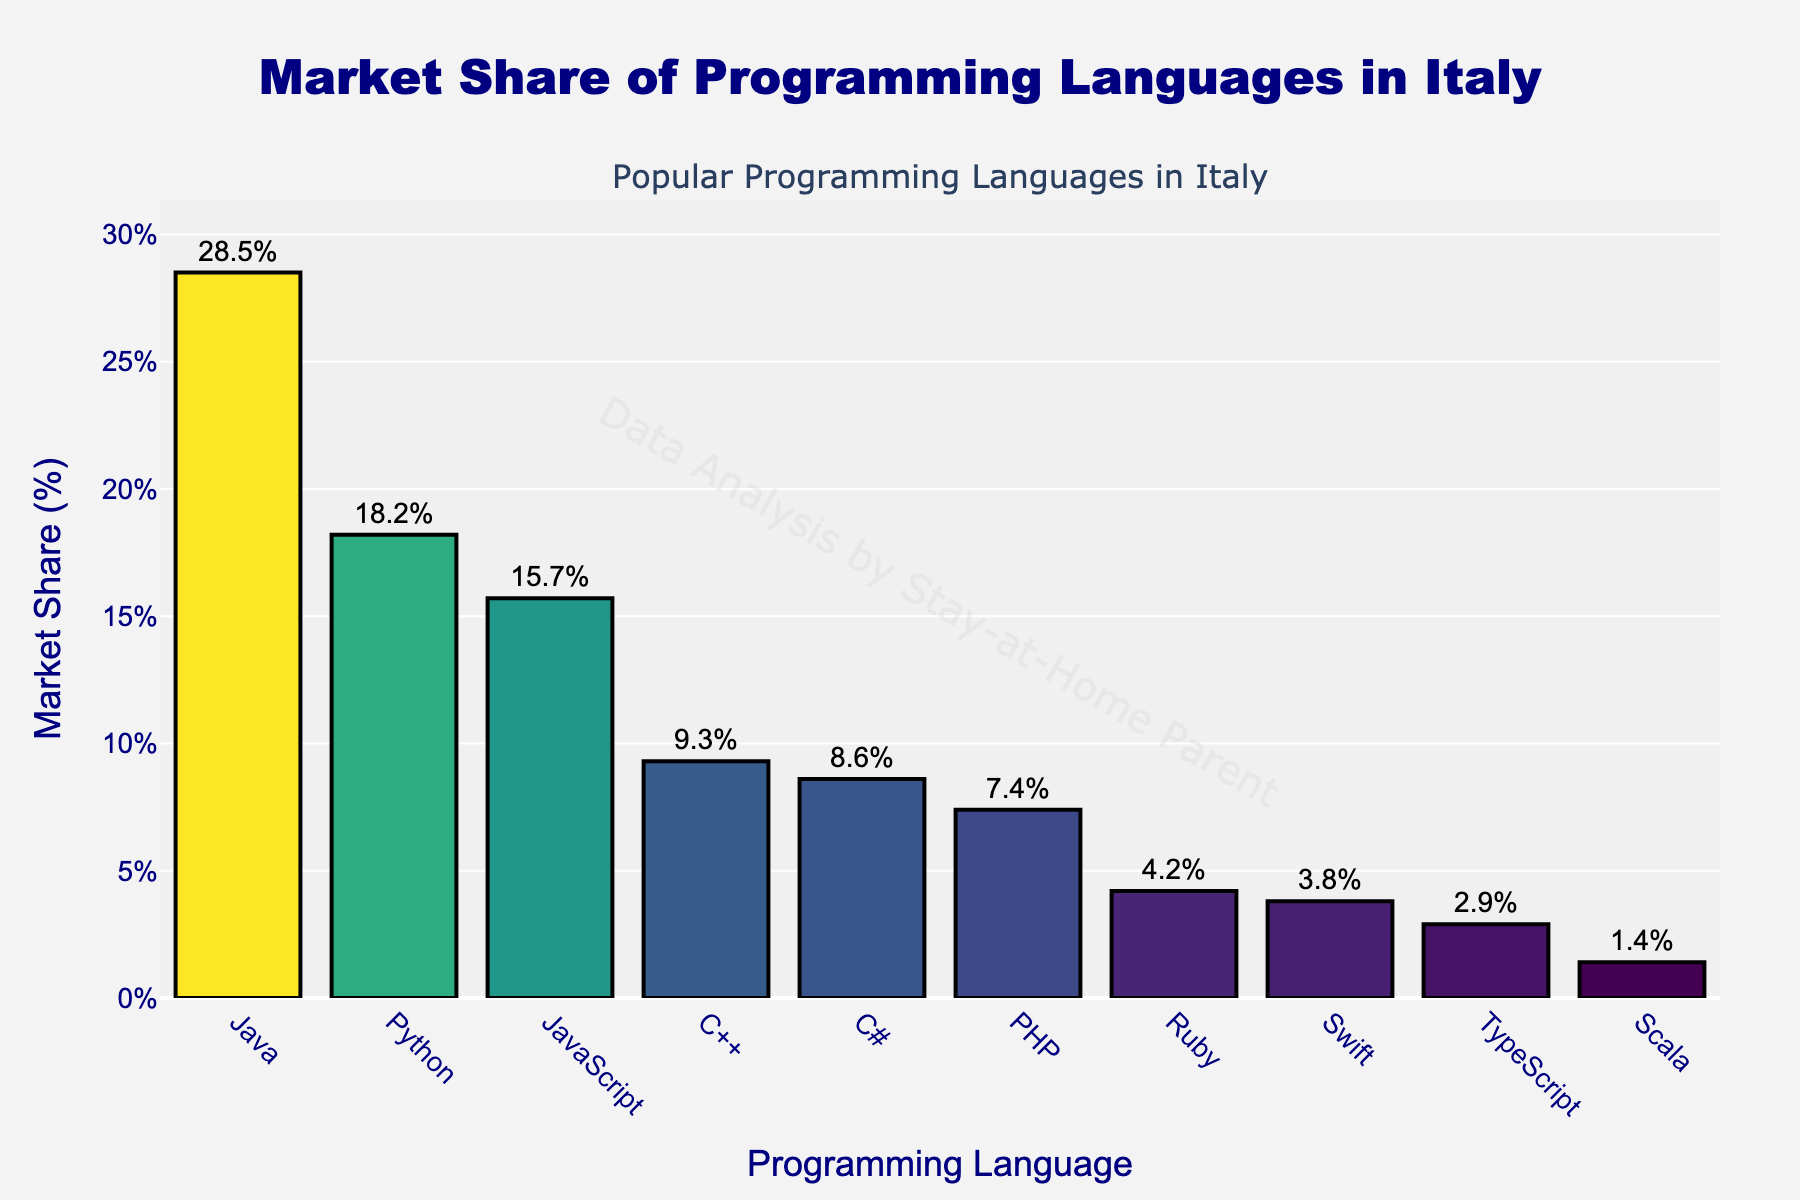What is the most popular programming language in Italy by market share? The figure shows the market share of various programming languages in Italy. The bar with the highest value represents the most popular language.
Answer: Java Which programming language has a market share greater than 10% but less than Java's market share? From the figure, identify the languages with market shares greater than 10%. Then, among those, find the one whose market share is less than Java's 28.5%.
Answer: Python Compare the market share of Python and PHP. How much higher is Python's market share compared to PHP? Identify the market shares of Python (18.2%) and PHP (7.4%). Subtract the market share of PHP from Python's.
Answer: 10.8% Which programming languages have a market share less than 5%? Look at the bars representing languages with a market share below 5%. These are Ruby, Swift, TypeScript, and Scala.
Answer: Ruby, Swift, TypeScript, Scala Is the combined market share of C# and C++ greater than JavaScript's market share? Find the market shares of C++ (9.3%) and C# (8.6%), and sum them up to get 17.9%. Compare this to JavaScript's market share of 15.7%.
Answer: Yes What is the market share difference between the least popular and the most popular programming languages? The least popular language is Scala (1.4%) and the most popular is Java (28.5%). Subtract Scala's share from Java's.
Answer: 27.1% Which language is positioned fifth in terms of market share? By examining the heights of the bars in descending order, the fifth highest bar corresponds to C#.
Answer: C# How does the market share of JavaScript compare to that of Ruby? Find the market share of JavaScript (15.7%) and Ruby (4.2%) and compare them. JavaScript's share is significantly higher.
Answer: JavaScript has a higher market share than Ruby What is the total market share of the top three programming languages? Sum the market shares of Java (28.5%), Python (18.2%), and JavaScript (15.7%).
Answer: 62.4% What is the average market share of all the programming languages listed? Add up the market shares of all languages (28.5 + 18.2 + 15.7 + 9.3 + 8.6 + 7.4 + 4.2 + 3.8 + 2.9 + 1.4) and divide by the number of languages (10).
Answer: 10.0% 